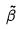Convert formula to latex. <formula><loc_0><loc_0><loc_500><loc_500>\tilde { \beta }</formula> 